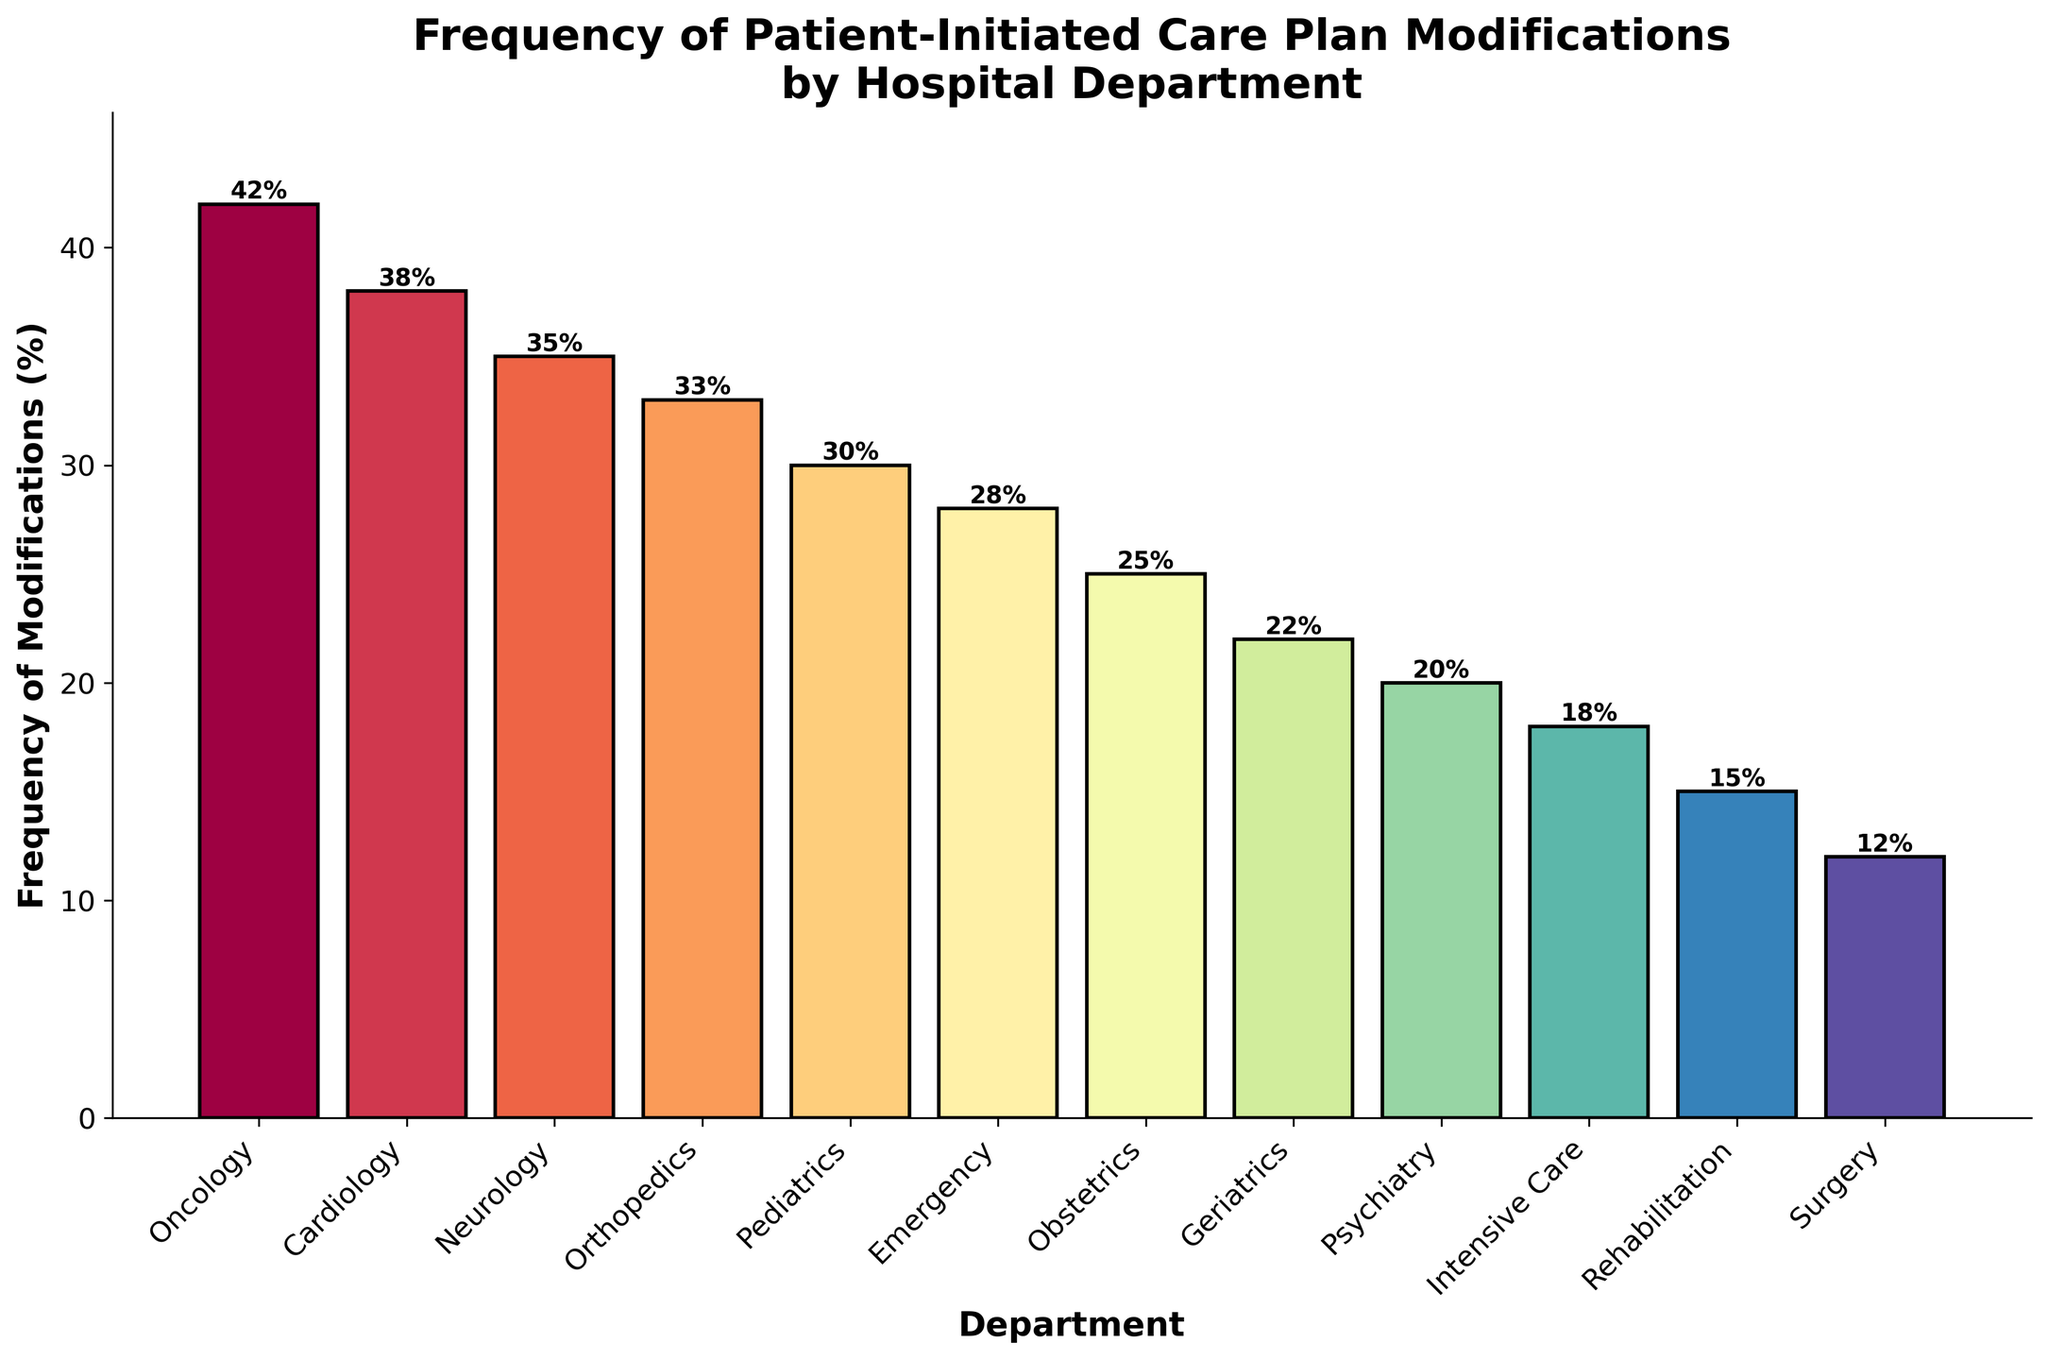Which department has the highest frequency of patient-initiated care plan modifications? The tallest bar represents Oncology, with a modification frequency of 42%. This can be confirmed by reading the values shown above each bar.
Answer: Oncology Which department has the lowest frequency of patient-initiated care plan modifications? The shortest bar represents Surgery, with a modification frequency of 12%. This can be confirmed by reading the values shown above the bar.
Answer: Surgery Compare the frequency of patient-initiated modifications between Oncology and Surgery departments. Oncology has a frequency of 42%, while Surgery has 12%. The difference is calculated by subtracting the smaller number from the larger one: 42% - 12% = 30%.
Answer: Oncology has 30% more modifications than Surgery What is the average frequency of patient-initiated modifications across all departments? Sum all the frequencies: 42 + 38 + 35 + 33 + 30 + 28 + 25 + 22 + 20 + 18 + 15 + 12 = 318. Divide by the number of departments (12) to find the average: 318 / 12 = 26.5%.
Answer: 26.5% Which department, besides Oncology, has over 35% frequency of patient-initiated modifications? Apart from Oncology (42%), the only other department with over 35% frequency is Cardiology, with a frequency of 38%.
Answer: Cardiology What is the percentage difference in patient-initiated modifications between Pediatrics and Intensive Care departments? Pediatrics has a frequency of 30%, and Intensive Care has 18%. Calculate the difference: 30% - 18% = 12%.
Answer: 12% In how many departments is the frequency of patient-initiated modifications below 20%? The departments with frequencies below 20% are Psychiatry (20%), Intensive Care (18%), Rehabilitation (15%), and Surgery (12%). There are four such departments.
Answer: 4 Combine the frequencies of modifications for Emergency and Obstetrics departments. How does this value compare to that of the Oncology department? Emergency has a frequency of 28% and Obstetrics has 25%. Combined, this is 28% + 25% = 53%. Oncology has a frequency of 42%. 53% is higher than 42%.
Answer: 53% is higher than 42% Rank the top three departments with the highest frequency of patient-initiated modifications. The departments with the highest frequencies are Oncology (42%), Cardiology (38%), and Neurology (35%). This can be seen by identifying the three tallest bars.
Answer: Oncology, Cardiology, Neurology 